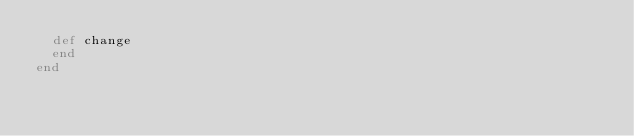<code> <loc_0><loc_0><loc_500><loc_500><_Ruby_>  def change
  end
end
</code> 